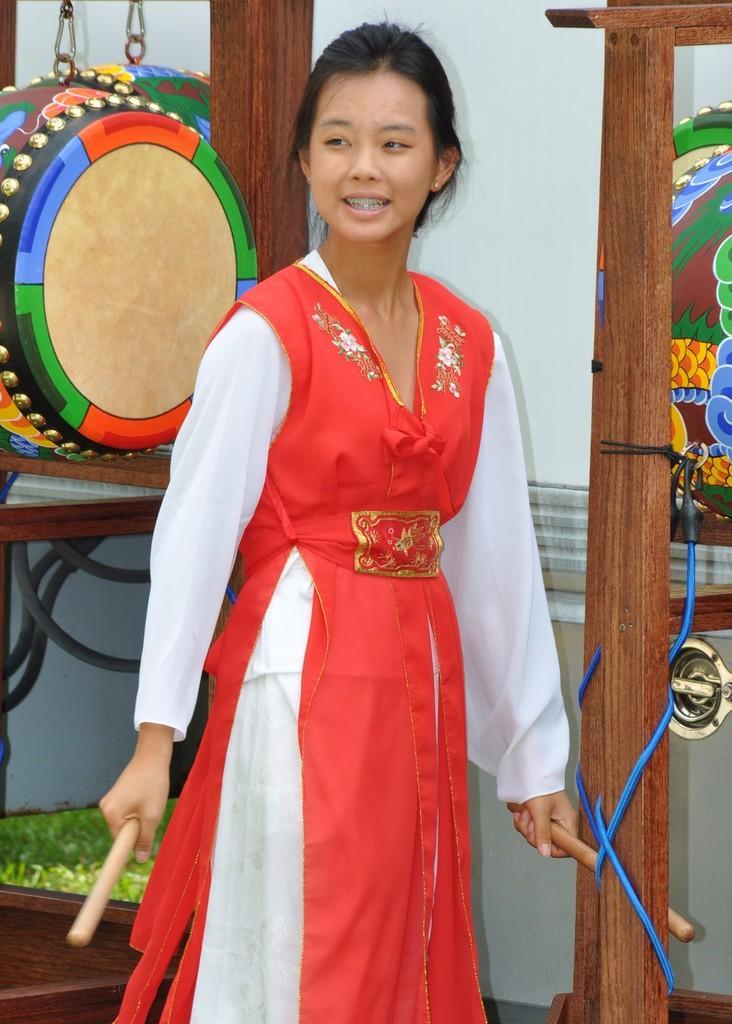Can you describe this image briefly? In this image there is a woman standing by holding the sticks in her hands, behind the woman there is a tabla hanged to the chain and there is a wooden structure with some ropes tied to it. In the background of the image there is a wall, in front of the wall there are pipes and some other objects. 